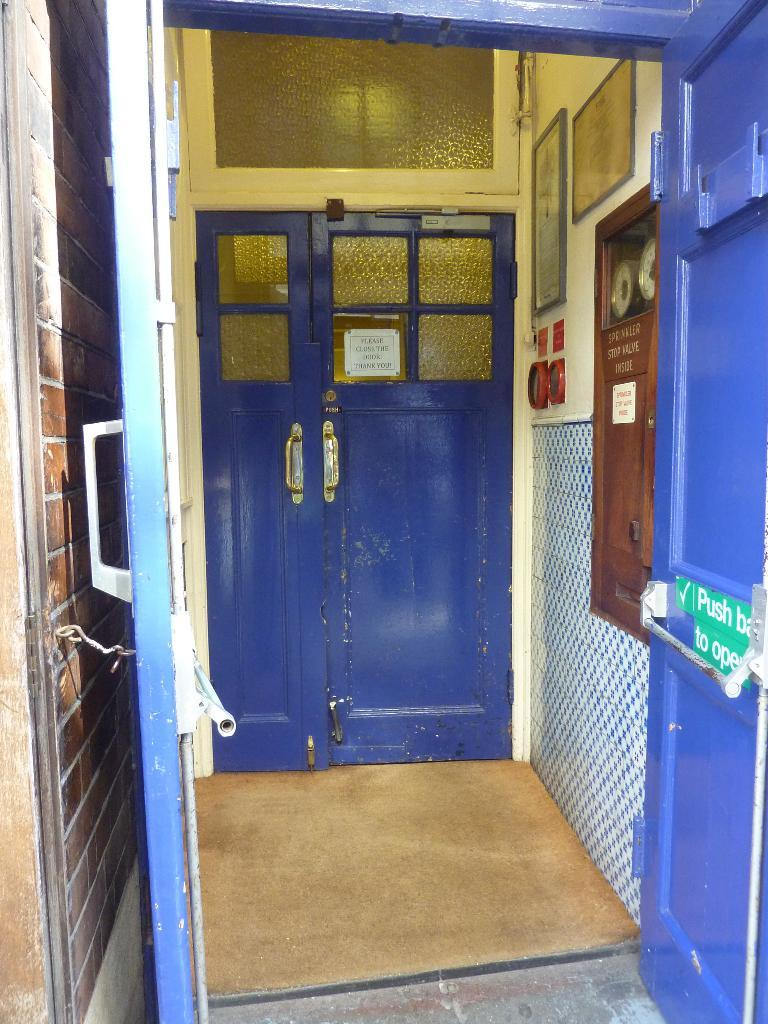What color are the doors in the image? The doors in the image are blue. What color is the wall in the image? The wall in the image is also blue. What can be seen on the blue wall in the image? There are objects on the wall in the image. How many vans are parked in front of the blue doors in the image? There is no van present in the image; it only features blue doors and a blue wall with objects on it. 